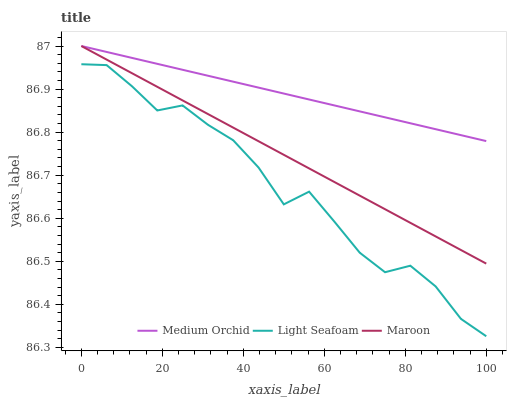Does Light Seafoam have the minimum area under the curve?
Answer yes or no. Yes. Does Medium Orchid have the maximum area under the curve?
Answer yes or no. Yes. Does Maroon have the minimum area under the curve?
Answer yes or no. No. Does Maroon have the maximum area under the curve?
Answer yes or no. No. Is Maroon the smoothest?
Answer yes or no. Yes. Is Light Seafoam the roughest?
Answer yes or no. Yes. Is Light Seafoam the smoothest?
Answer yes or no. No. Is Maroon the roughest?
Answer yes or no. No. Does Light Seafoam have the lowest value?
Answer yes or no. Yes. Does Maroon have the lowest value?
Answer yes or no. No. Does Maroon have the highest value?
Answer yes or no. Yes. Does Light Seafoam have the highest value?
Answer yes or no. No. Is Light Seafoam less than Medium Orchid?
Answer yes or no. Yes. Is Maroon greater than Light Seafoam?
Answer yes or no. Yes. Does Maroon intersect Medium Orchid?
Answer yes or no. Yes. Is Maroon less than Medium Orchid?
Answer yes or no. No. Is Maroon greater than Medium Orchid?
Answer yes or no. No. Does Light Seafoam intersect Medium Orchid?
Answer yes or no. No. 